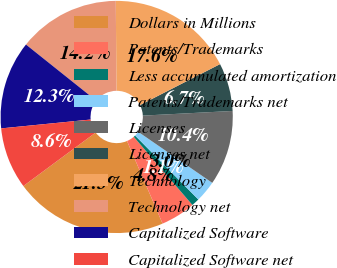Convert chart. <chart><loc_0><loc_0><loc_500><loc_500><pie_chart><fcel>Dollars in Millions<fcel>Patents/Trademarks<fcel>Less accumulated amortization<fcel>Patents/Trademarks net<fcel>Licenses<fcel>Licenses net<fcel>Technology<fcel>Technology net<fcel>Capitalized Software<fcel>Capitalized Software net<nl><fcel>21.33%<fcel>4.84%<fcel>1.11%<fcel>2.98%<fcel>10.43%<fcel>6.7%<fcel>17.6%<fcel>14.16%<fcel>12.29%<fcel>8.57%<nl></chart> 